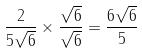<formula> <loc_0><loc_0><loc_500><loc_500>\frac { 2 } { 5 \sqrt { 6 } } \times \frac { \sqrt { 6 } } { \sqrt { 6 } } = \frac { 6 \sqrt { 6 } } { 5 }</formula> 